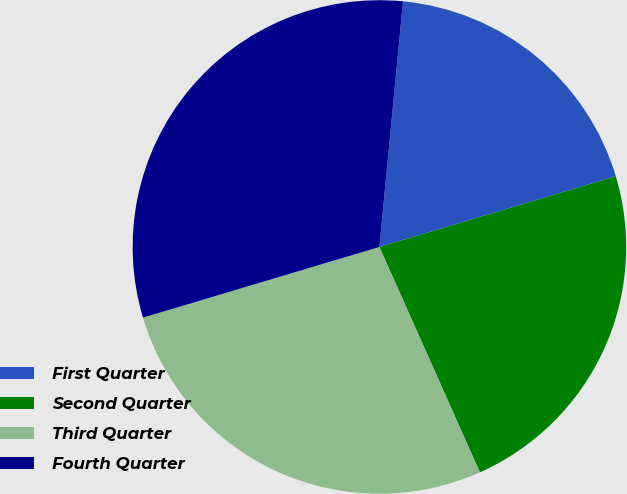<chart> <loc_0><loc_0><loc_500><loc_500><pie_chart><fcel>First Quarter<fcel>Second Quarter<fcel>Third Quarter<fcel>Fourth Quarter<nl><fcel>18.85%<fcel>22.95%<fcel>27.05%<fcel>31.15%<nl></chart> 